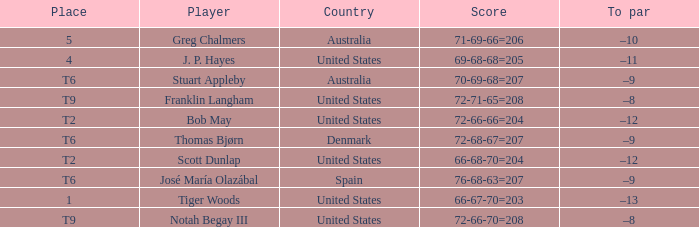What is the place of the player with a 66-68-70=204 score? T2. 